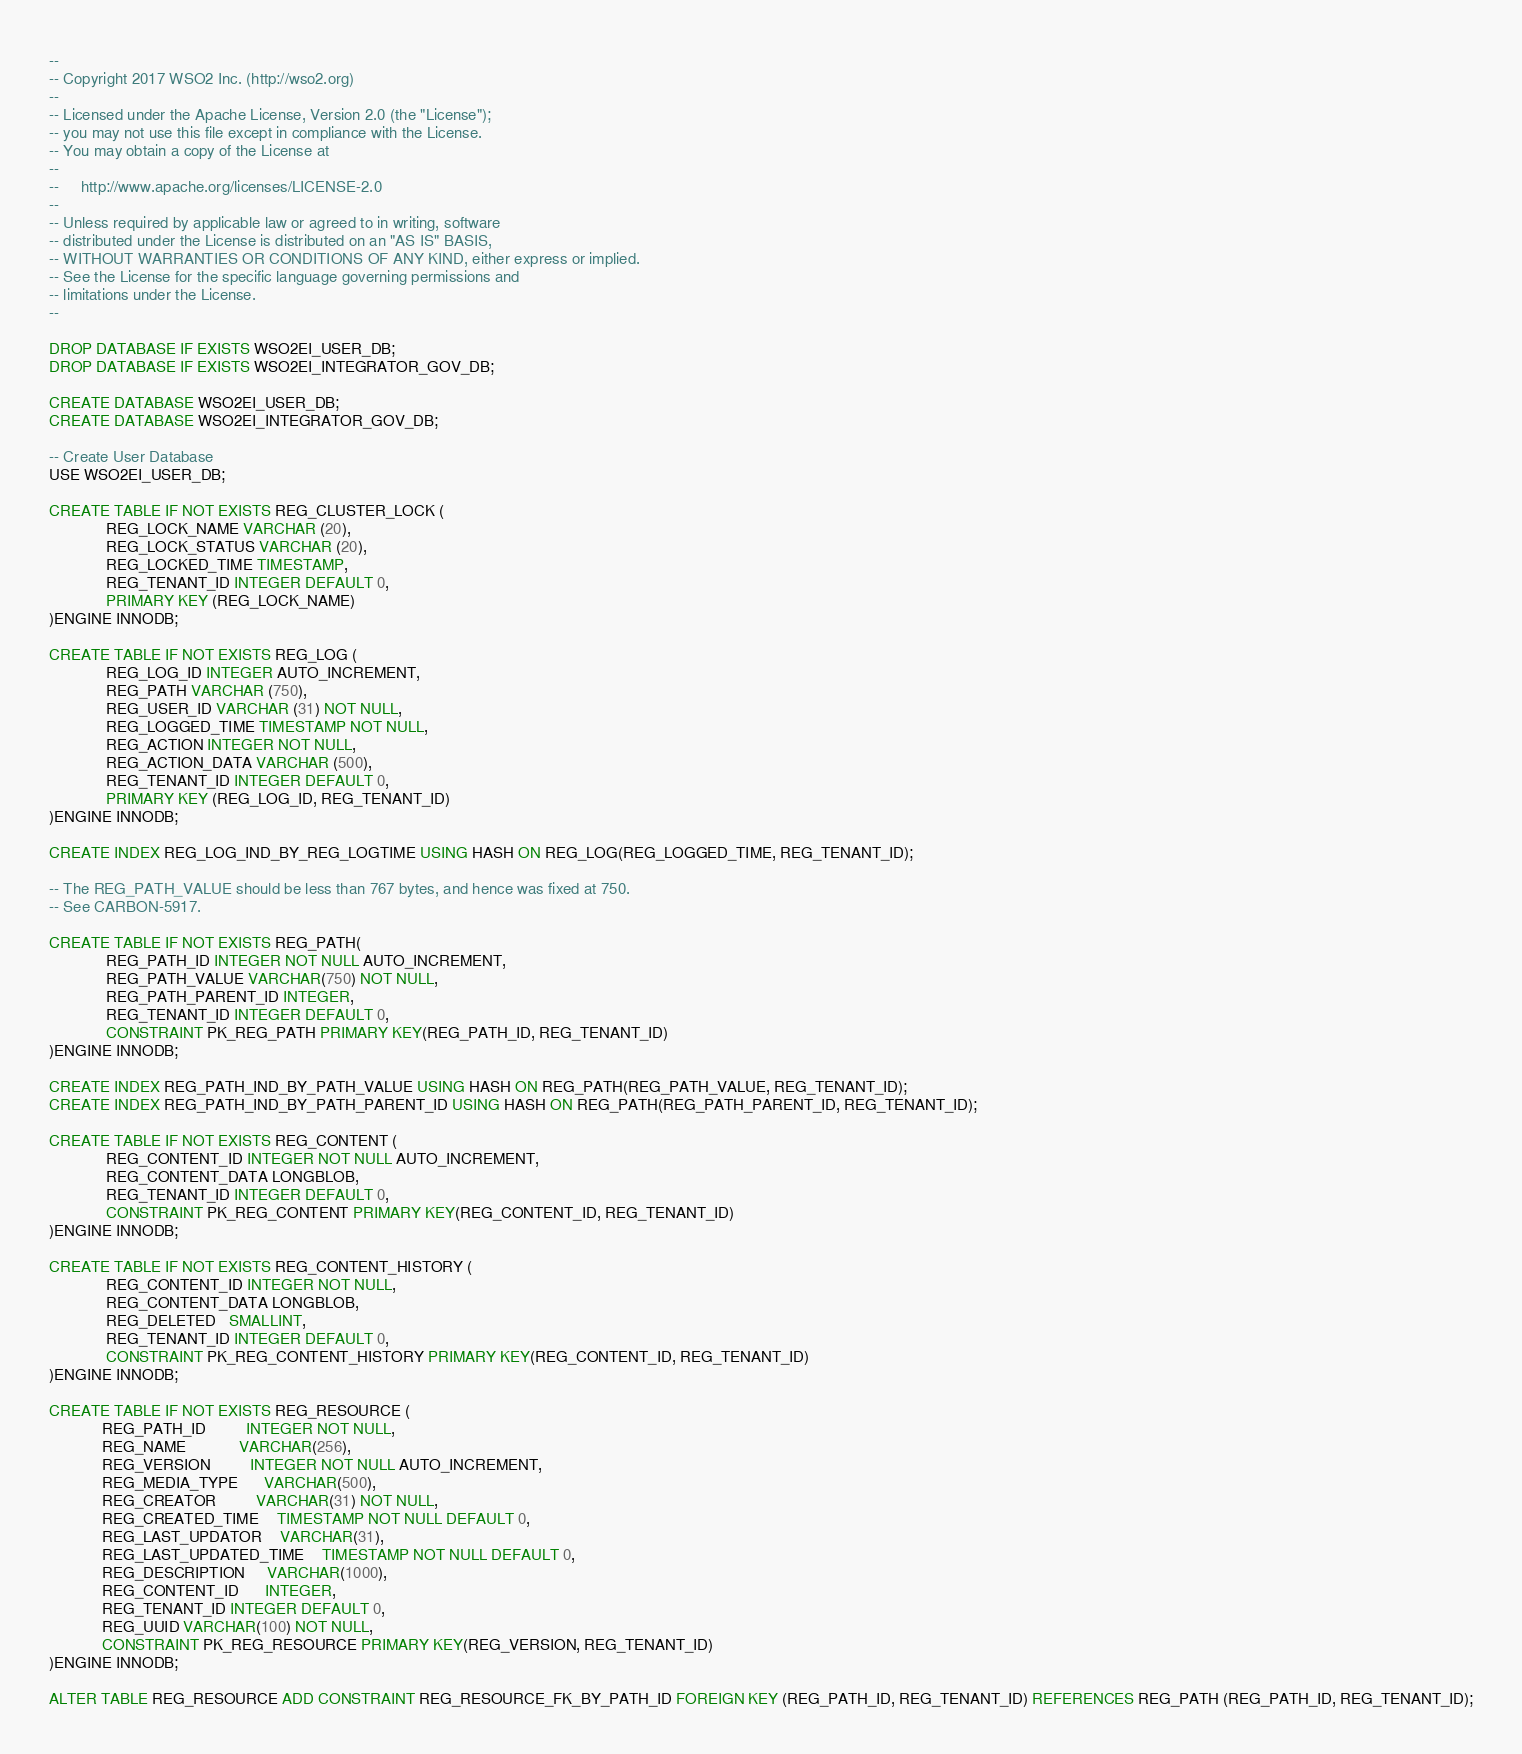<code> <loc_0><loc_0><loc_500><loc_500><_SQL_>--
-- Copyright 2017 WSO2 Inc. (http://wso2.org)
--
-- Licensed under the Apache License, Version 2.0 (the "License");
-- you may not use this file except in compliance with the License.
-- You may obtain a copy of the License at
--
--     http://www.apache.org/licenses/LICENSE-2.0
--
-- Unless required by applicable law or agreed to in writing, software
-- distributed under the License is distributed on an "AS IS" BASIS,
-- WITHOUT WARRANTIES OR CONDITIONS OF ANY KIND, either express or implied.
-- See the License for the specific language governing permissions and
-- limitations under the License.
--

DROP DATABASE IF EXISTS WSO2EI_USER_DB;
DROP DATABASE IF EXISTS WSO2EI_INTEGRATOR_GOV_DB;

CREATE DATABASE WSO2EI_USER_DB;
CREATE DATABASE WSO2EI_INTEGRATOR_GOV_DB;

-- Create User Database
USE WSO2EI_USER_DB;

CREATE TABLE IF NOT EXISTS REG_CLUSTER_LOCK (
             REG_LOCK_NAME VARCHAR (20),
             REG_LOCK_STATUS VARCHAR (20),
             REG_LOCKED_TIME TIMESTAMP,
             REG_TENANT_ID INTEGER DEFAULT 0,
             PRIMARY KEY (REG_LOCK_NAME)
)ENGINE INNODB;

CREATE TABLE IF NOT EXISTS REG_LOG (
             REG_LOG_ID INTEGER AUTO_INCREMENT,
             REG_PATH VARCHAR (750),
             REG_USER_ID VARCHAR (31) NOT NULL,
             REG_LOGGED_TIME TIMESTAMP NOT NULL,
             REG_ACTION INTEGER NOT NULL,
             REG_ACTION_DATA VARCHAR (500),
             REG_TENANT_ID INTEGER DEFAULT 0,
             PRIMARY KEY (REG_LOG_ID, REG_TENANT_ID)
)ENGINE INNODB;

CREATE INDEX REG_LOG_IND_BY_REG_LOGTIME USING HASH ON REG_LOG(REG_LOGGED_TIME, REG_TENANT_ID);

-- The REG_PATH_VALUE should be less than 767 bytes, and hence was fixed at 750.
-- See CARBON-5917.

CREATE TABLE IF NOT EXISTS REG_PATH(
             REG_PATH_ID INTEGER NOT NULL AUTO_INCREMENT,
             REG_PATH_VALUE VARCHAR(750) NOT NULL,
             REG_PATH_PARENT_ID INTEGER,
             REG_TENANT_ID INTEGER DEFAULT 0,
             CONSTRAINT PK_REG_PATH PRIMARY KEY(REG_PATH_ID, REG_TENANT_ID)
)ENGINE INNODB;

CREATE INDEX REG_PATH_IND_BY_PATH_VALUE USING HASH ON REG_PATH(REG_PATH_VALUE, REG_TENANT_ID);
CREATE INDEX REG_PATH_IND_BY_PATH_PARENT_ID USING HASH ON REG_PATH(REG_PATH_PARENT_ID, REG_TENANT_ID);

CREATE TABLE IF NOT EXISTS REG_CONTENT (
             REG_CONTENT_ID INTEGER NOT NULL AUTO_INCREMENT,
             REG_CONTENT_DATA LONGBLOB,
             REG_TENANT_ID INTEGER DEFAULT 0,
             CONSTRAINT PK_REG_CONTENT PRIMARY KEY(REG_CONTENT_ID, REG_TENANT_ID)
)ENGINE INNODB;

CREATE TABLE IF NOT EXISTS REG_CONTENT_HISTORY (
             REG_CONTENT_ID INTEGER NOT NULL,
             REG_CONTENT_DATA LONGBLOB,
             REG_DELETED   SMALLINT,
             REG_TENANT_ID INTEGER DEFAULT 0,
             CONSTRAINT PK_REG_CONTENT_HISTORY PRIMARY KEY(REG_CONTENT_ID, REG_TENANT_ID)
)ENGINE INNODB;

CREATE TABLE IF NOT EXISTS REG_RESOURCE (
            REG_PATH_ID         INTEGER NOT NULL,
            REG_NAME            VARCHAR(256),
            REG_VERSION         INTEGER NOT NULL AUTO_INCREMENT,
            REG_MEDIA_TYPE      VARCHAR(500),
            REG_CREATOR         VARCHAR(31) NOT NULL,
            REG_CREATED_TIME    TIMESTAMP NOT NULL DEFAULT 0,
            REG_LAST_UPDATOR    VARCHAR(31),
            REG_LAST_UPDATED_TIME    TIMESTAMP NOT NULL DEFAULT 0,
            REG_DESCRIPTION     VARCHAR(1000),
            REG_CONTENT_ID      INTEGER,
            REG_TENANT_ID INTEGER DEFAULT 0,
            REG_UUID VARCHAR(100) NOT NULL,
            CONSTRAINT PK_REG_RESOURCE PRIMARY KEY(REG_VERSION, REG_TENANT_ID)
)ENGINE INNODB;

ALTER TABLE REG_RESOURCE ADD CONSTRAINT REG_RESOURCE_FK_BY_PATH_ID FOREIGN KEY (REG_PATH_ID, REG_TENANT_ID) REFERENCES REG_PATH (REG_PATH_ID, REG_TENANT_ID);</code> 